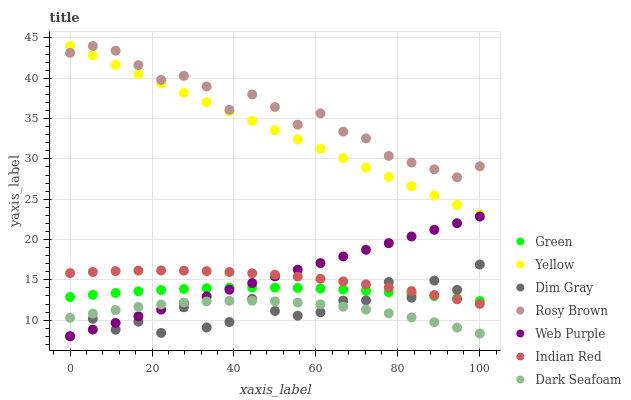Does Dark Seafoam have the minimum area under the curve?
Answer yes or no. Yes. Does Rosy Brown have the maximum area under the curve?
Answer yes or no. Yes. Does Rosy Brown have the minimum area under the curve?
Answer yes or no. No. Does Dark Seafoam have the maximum area under the curve?
Answer yes or no. No. Is Web Purple the smoothest?
Answer yes or no. Yes. Is Dim Gray the roughest?
Answer yes or no. Yes. Is Rosy Brown the smoothest?
Answer yes or no. No. Is Rosy Brown the roughest?
Answer yes or no. No. Does Dim Gray have the lowest value?
Answer yes or no. Yes. Does Dark Seafoam have the lowest value?
Answer yes or no. No. Does Yellow have the highest value?
Answer yes or no. Yes. Does Dark Seafoam have the highest value?
Answer yes or no. No. Is Web Purple less than Rosy Brown?
Answer yes or no. Yes. Is Rosy Brown greater than Dark Seafoam?
Answer yes or no. Yes. Does Web Purple intersect Indian Red?
Answer yes or no. Yes. Is Web Purple less than Indian Red?
Answer yes or no. No. Is Web Purple greater than Indian Red?
Answer yes or no. No. Does Web Purple intersect Rosy Brown?
Answer yes or no. No. 